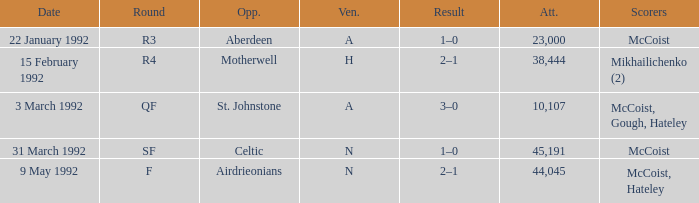What is the result with an attendance larger than 10,107 and Celtic as the opponent? 1–0. 